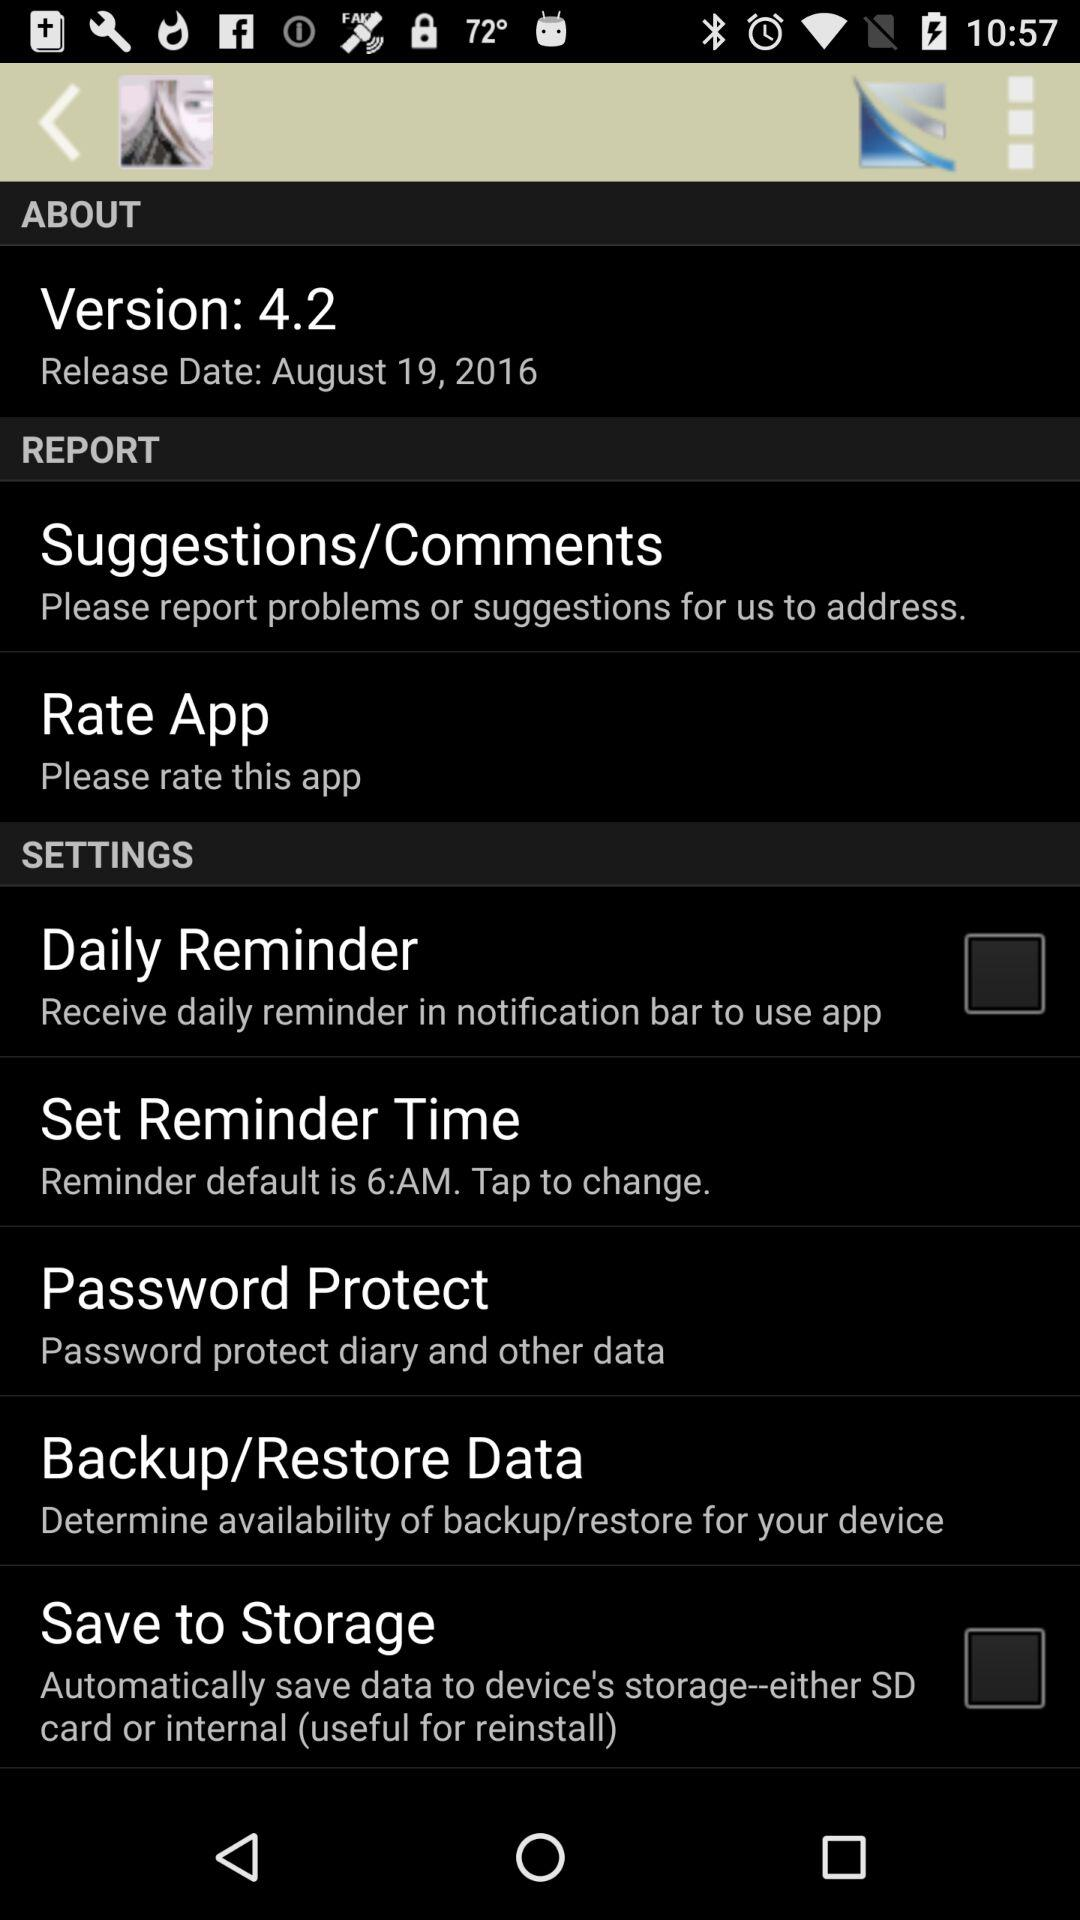What is the default reminder time? The default reminder time is 6 a.m. 